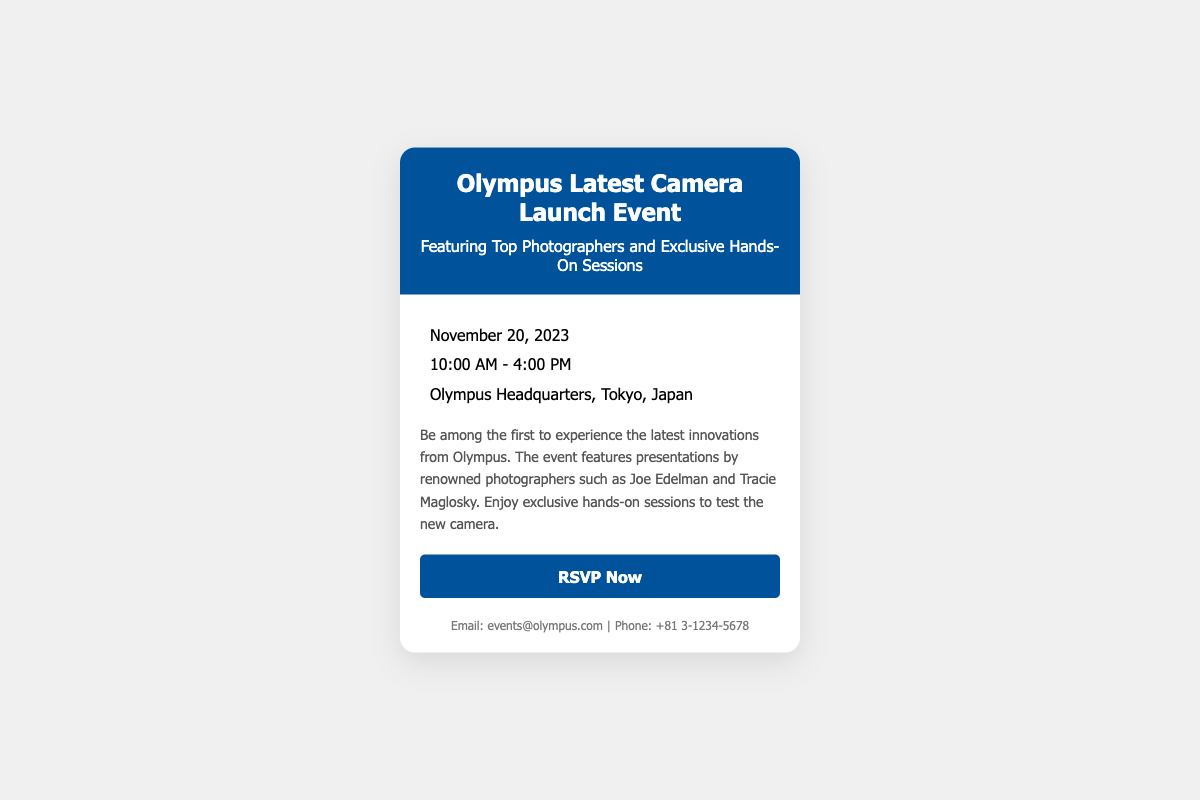What is the event date? The event date is specified in the document under the details section.
Answer: November 20, 2023 What time does the event start? The start time is provided in the details section of the document.
Answer: 10:00 AM Where is the event being held? The location of the event is noted in the details section of the RSVP card.
Answer: Olympus Headquarters, Tokyo, Japan Who are some of the featured photographers? The document lists notable photographers featured at the event.
Answer: Joe Edelman and Tracie Maglosky What can attendees do at the event? The document describes the activities available at the event, including hands-on experiences.
Answer: Exclusive hands-on sessions What type of event is this? The RSVP card describes the nature of the event prominently in the title and description.
Answer: Camera launch event What will attendees be among the first to do? The document mentions an opportunity attendees will have regarding the latest innovations.
Answer: Experience the latest innovations How can someone RSVP for the event? The RSVP method is indicated by a call-to-action button with a link.
Answer: RSVP Now What is the contact email for inquiries? The document provides contact information at the bottom of the card.
Answer: events@olympus.com 